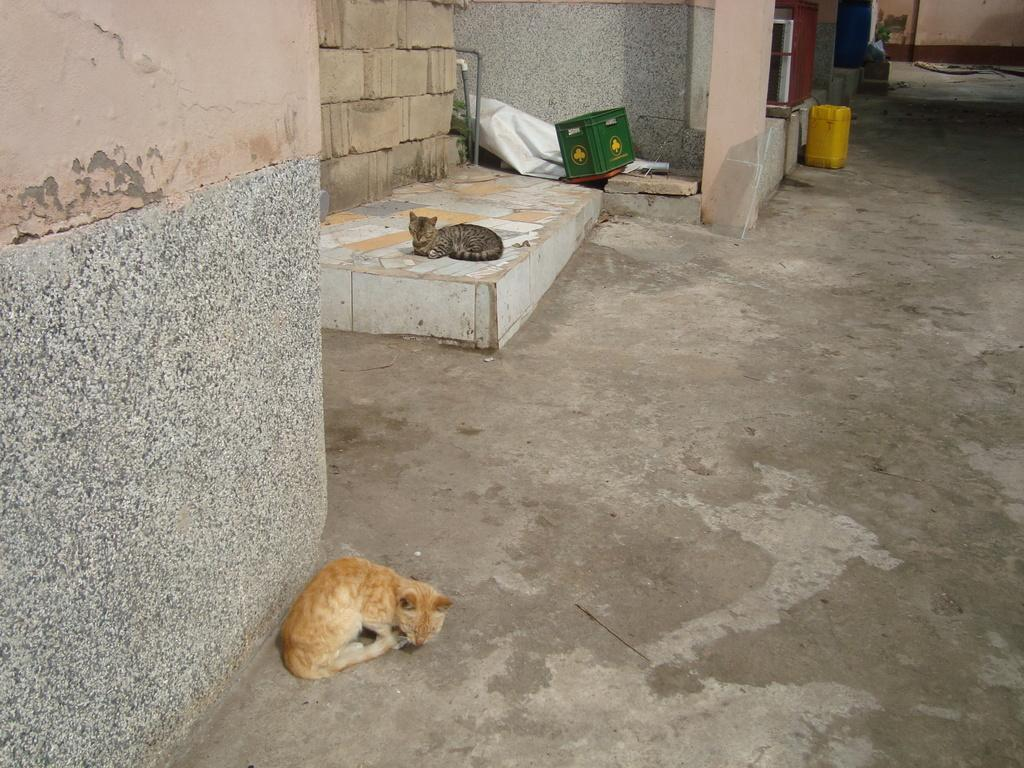Where is the first cat located in the image? The first cat is sitting on the ground at the wall. What is the second cat doing in the image? The second cat is sitting on a platform in the background. What type of objects can be seen in the background? Pipes, a box, a banner, a water can, and a pillar are visible in the background. Are there any other objects present in the background? Yes, there are other objects present in the background. What type of sea creatures can be seen swimming in the image? There are no sea creatures present in the image; it features cats and various objects in a non-aquatic setting. What reward is the cat receiving for sitting on the ground at the wall? There is no reward visible in the image, and the cat's actions do not suggest that it is receiving any form of reward. 